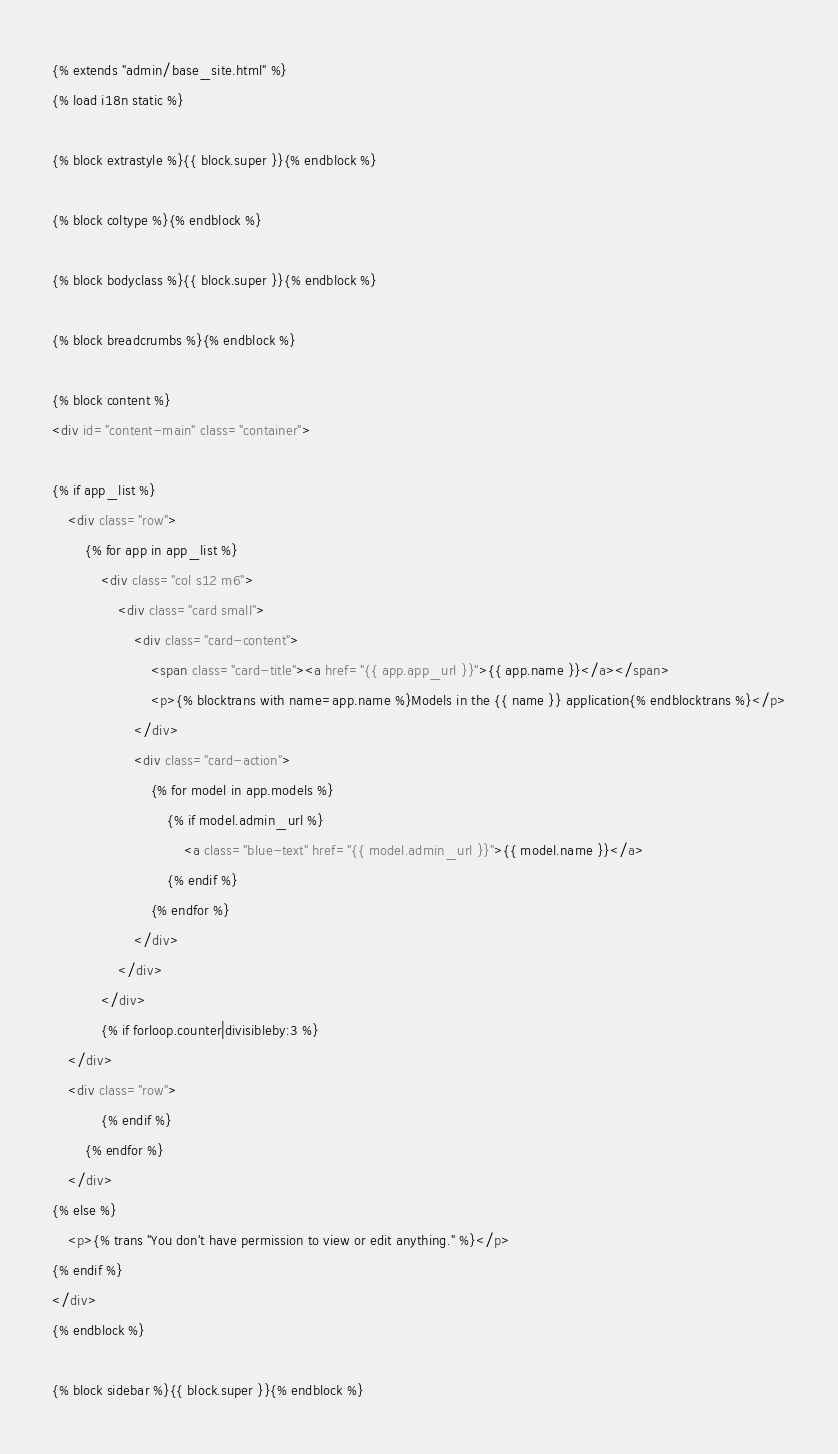<code> <loc_0><loc_0><loc_500><loc_500><_HTML_>{% extends "admin/base_site.html" %}
{% load i18n static %}

{% block extrastyle %}{{ block.super }}{% endblock %}

{% block coltype %}{% endblock %}

{% block bodyclass %}{{ block.super }}{% endblock %}

{% block breadcrumbs %}{% endblock %}

{% block content %}
<div id="content-main" class="container">

{% if app_list %}
    <div class="row">
        {% for app in app_list %}
            <div class="col s12 m6">
                <div class="card small">
                    <div class="card-content">
                        <span class="card-title"><a href="{{ app.app_url }}">{{ app.name }}</a></span>
                        <p>{% blocktrans with name=app.name %}Models in the {{ name }} application{% endblocktrans %}</p>
                    </div>
                    <div class="card-action">
                        {% for model in app.models %}
                            {% if model.admin_url %}
                                <a class="blue-text" href="{{ model.admin_url }}">{{ model.name }}</a>
                            {% endif %}
                        {% endfor %}
                    </div>
                </div>
            </div>
            {% if forloop.counter|divisibleby:3 %}
    </div>
    <div class="row">
            {% endif %}
        {% endfor %}
    </div>
{% else %}
    <p>{% trans "You don't have permission to view or edit anything." %}</p>
{% endif %}
</div>
{% endblock %}

{% block sidebar %}{{ block.super }}{% endblock %}
</code> 